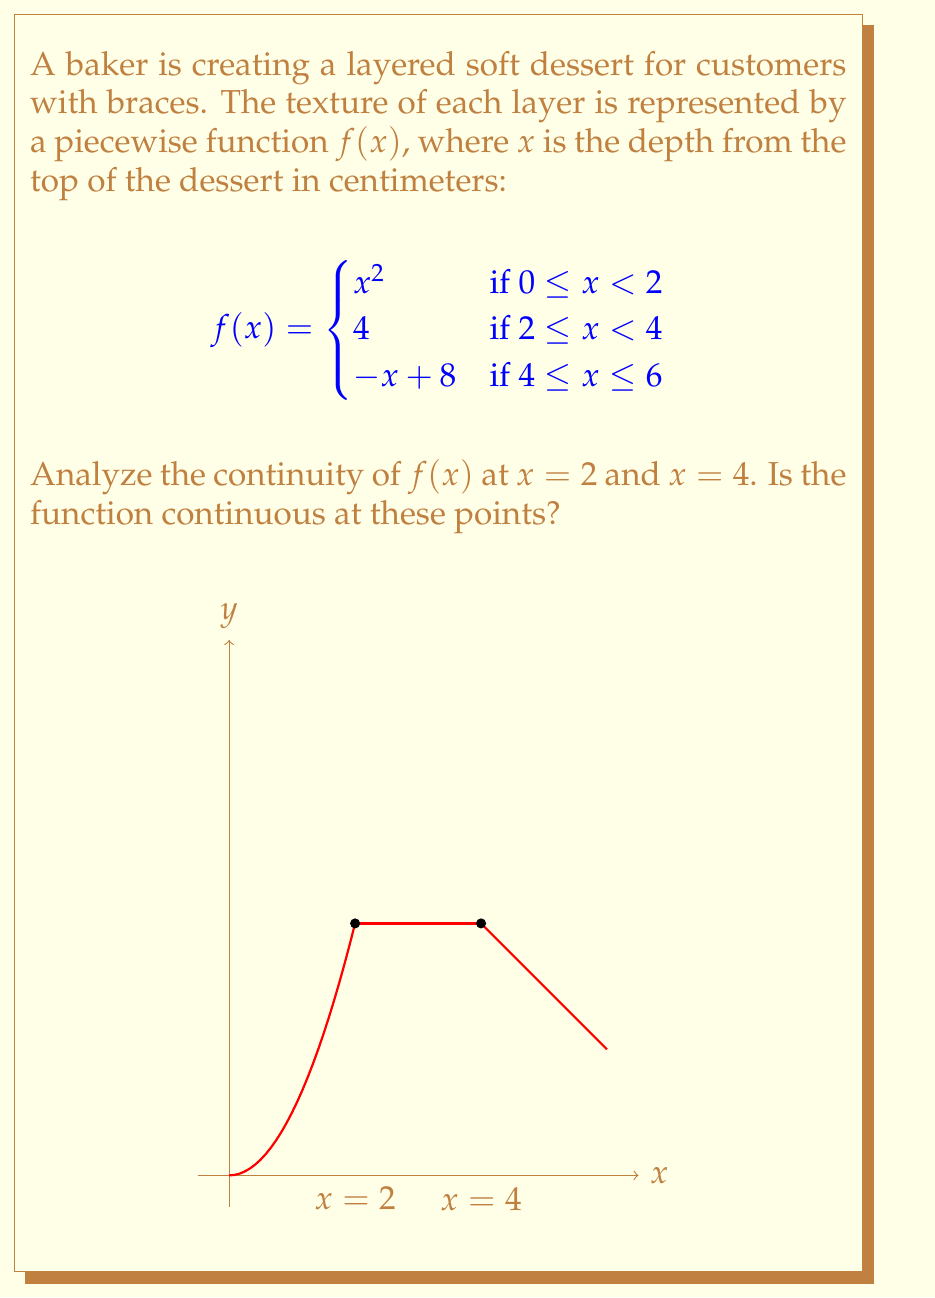Provide a solution to this math problem. To analyze the continuity of $f(x)$ at $x = 2$ and $x = 4$, we need to check three conditions for each point:

1. $f(x)$ is defined at the point
2. $\lim_{x \to c^-} f(x)$ exists
3. $\lim_{x \to c^+} f(x)$ exists
4. $\lim_{x \to c^-} f(x) = \lim_{x \to c^+} f(x) = f(c)$

For $x = 2$:

1. $f(2)$ is defined: $f(2) = 4$
2. $\lim_{x \to 2^-} f(x) = \lim_{x \to 2^-} x^2 = 4$
3. $\lim_{x \to 2^+} f(x) = 4$
4. $\lim_{x \to 2^-} f(x) = \lim_{x \to 2^+} f(x) = f(2) = 4$

All conditions are satisfied, so $f(x)$ is continuous at $x = 2$.

For $x = 4$:

1. $f(4)$ is defined: $f(4) = 4$
2. $\lim_{x \to 4^-} f(x) = 4$
3. $\lim_{x \to 4^+} f(x) = \lim_{x \to 4^+} (-x + 8) = 4$
4. $\lim_{x \to 4^-} f(x) = \lim_{x \to 4^+} f(x) = f(4) = 4$

All conditions are satisfied, so $f(x)$ is continuous at $x = 4$.
Answer: $f(x)$ is continuous at both $x = 2$ and $x = 4$. 